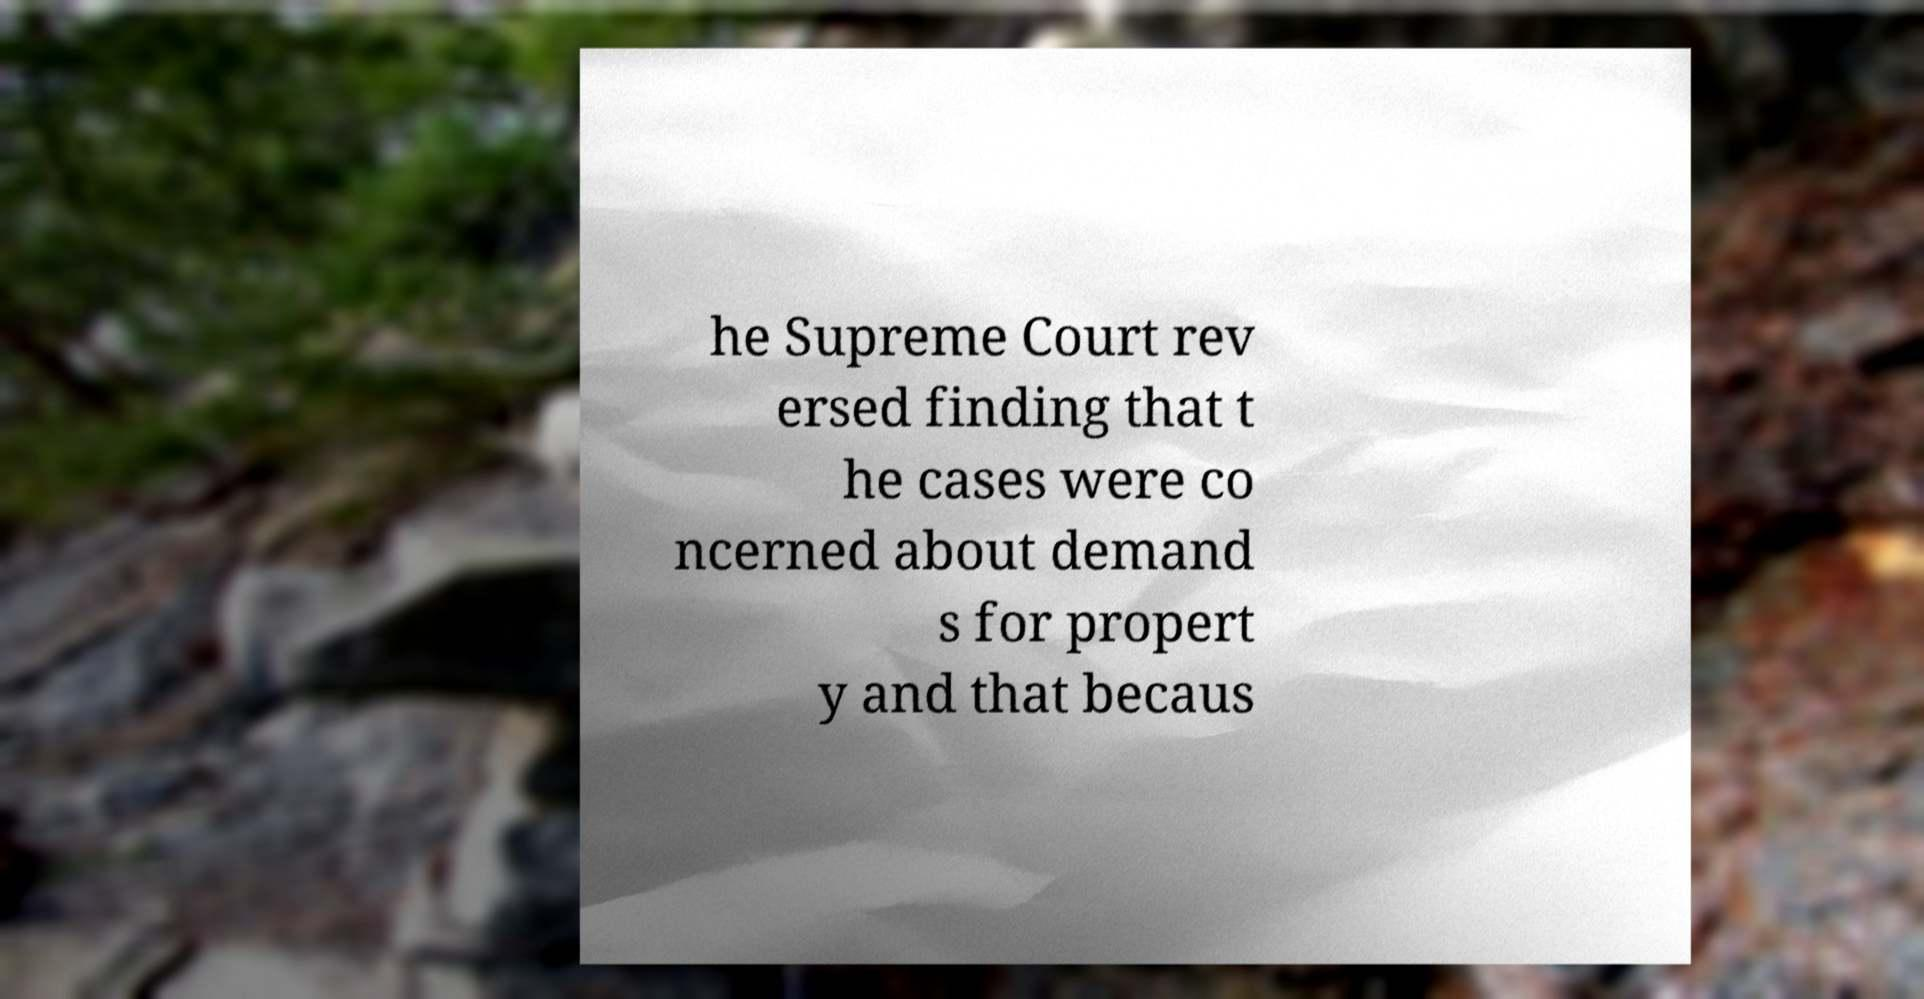For documentation purposes, I need the text within this image transcribed. Could you provide that? he Supreme Court rev ersed finding that t he cases were co ncerned about demand s for propert y and that becaus 